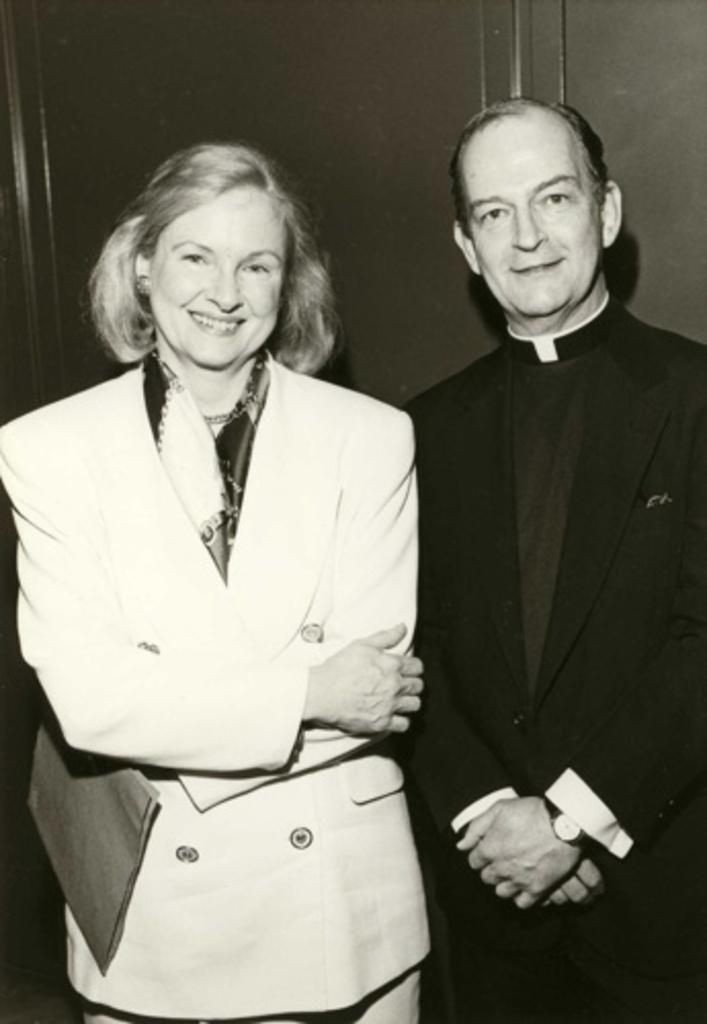What is the color scheme of the image? The image is black and white. Can you describe the people in the image? There is a lady in the image, and she is holding something in her hand. There is also a man in the image, and he is wearing a watch. What can be seen in the background of the image? There is a wall in the background of the image. How many sacks are visible in the image? There are no sacks present in the image. 